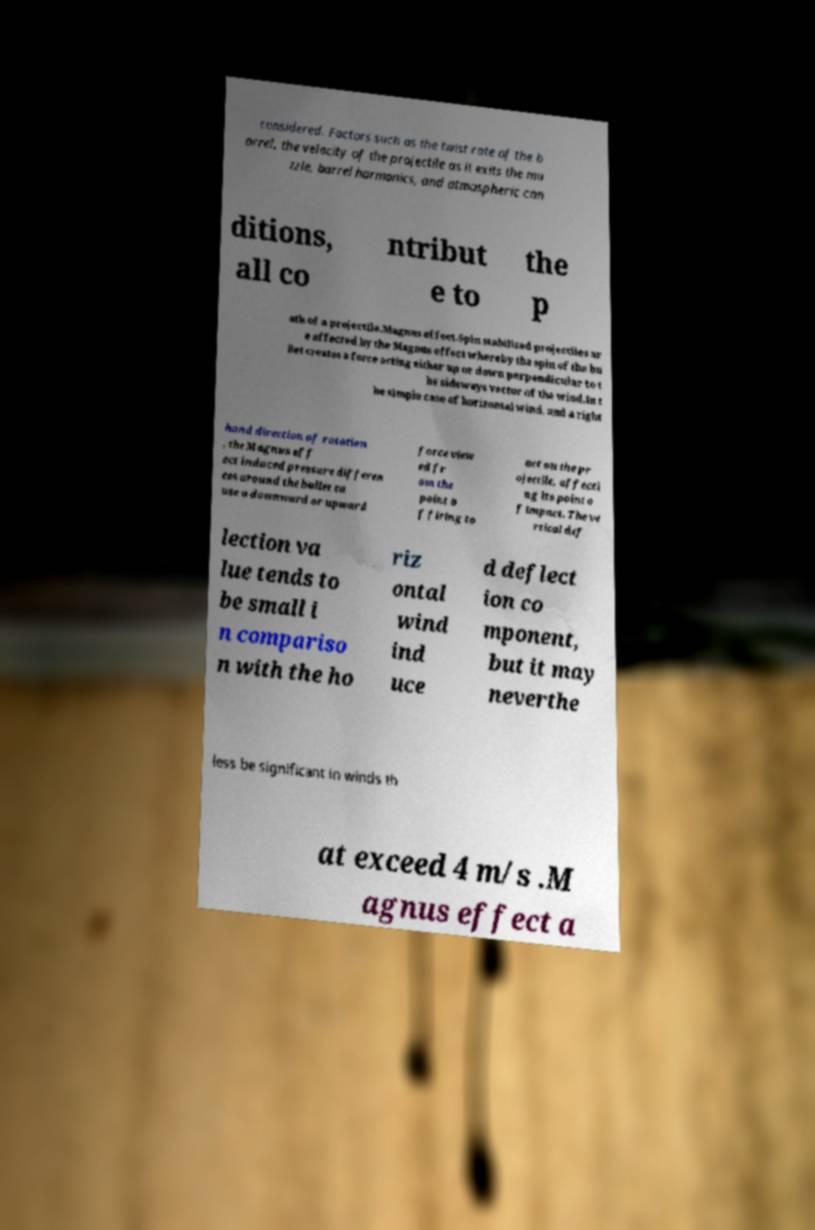I need the written content from this picture converted into text. Can you do that? considered. Factors such as the twist rate of the b arrel, the velocity of the projectile as it exits the mu zzle, barrel harmonics, and atmospheric con ditions, all co ntribut e to the p ath of a projectile.Magnus effect.Spin stabilized projectiles ar e affected by the Magnus effect whereby the spin of the bu llet creates a force acting either up or down perpendicular to t he sideways vector of the wind.In t he simple case of horizontal wind, and a right hand direction of rotation , the Magnus eff ect induced pressure differen ces around the bullet ca use a downward or upward force view ed fr om the point o f firing to act on the pr ojectile, affecti ng its point o f impact. The ve rtical def lection va lue tends to be small i n compariso n with the ho riz ontal wind ind uce d deflect ion co mponent, but it may neverthe less be significant in winds th at exceed 4 m/s .M agnus effect a 